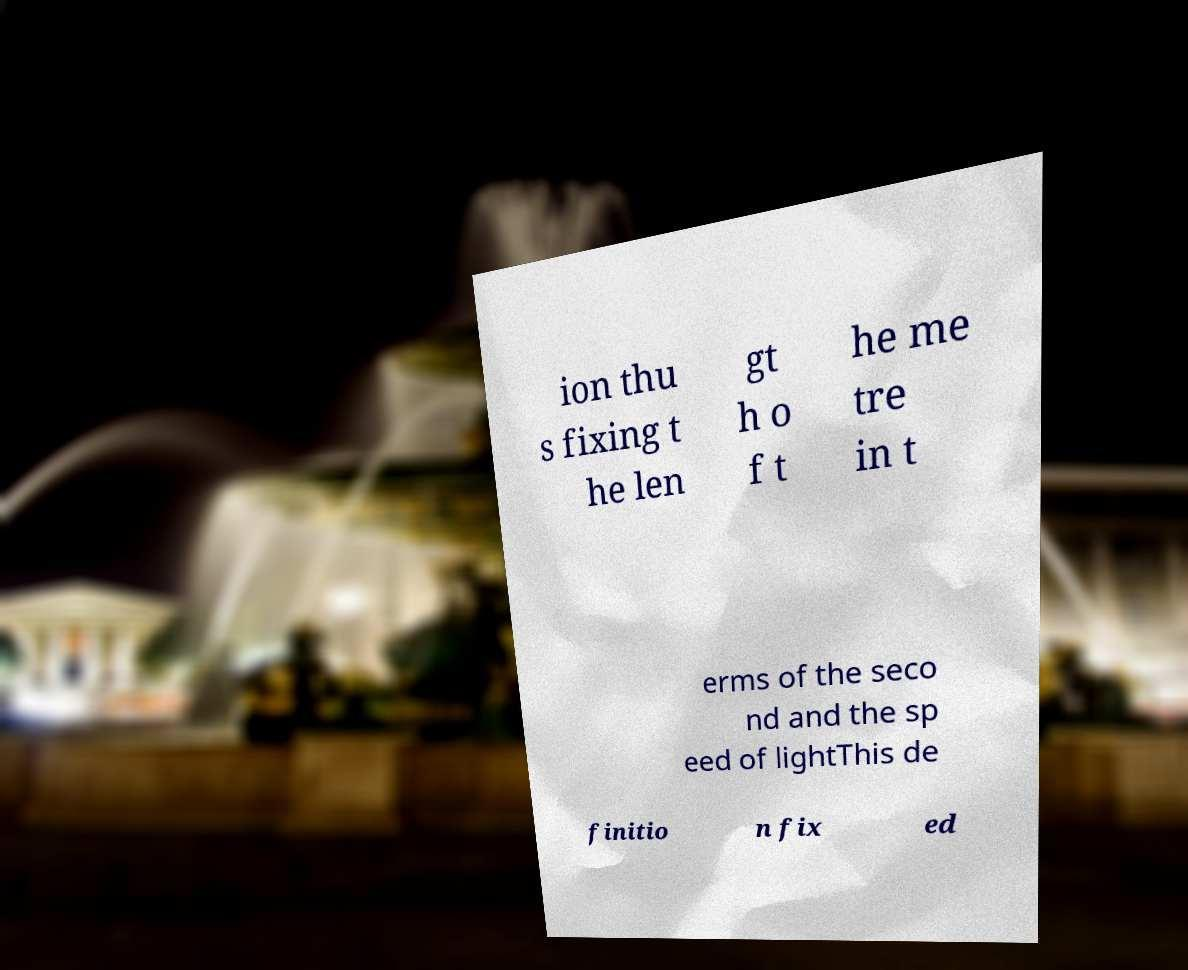Please identify and transcribe the text found in this image. ion thu s fixing t he len gt h o f t he me tre in t erms of the seco nd and the sp eed of lightThis de finitio n fix ed 